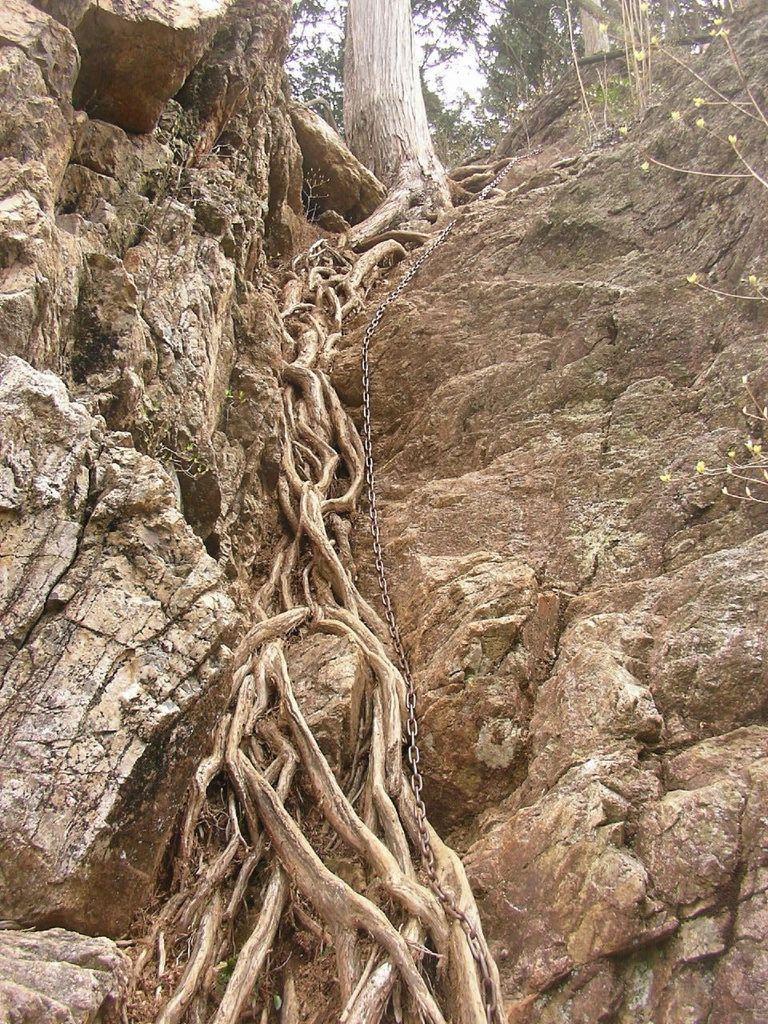What type of plant or vegetation can be seen in the image? There are roots visible in the image. What object can be seen on the hill in the image? There is a chain on the hill in the image. What is located at the top of the image? There is a stem at the top of the image. What type of skirt is hanging from the stem at the top of the image? There is no skirt present in the image; it features roots, a chain, and a stem. Can you spot any jellyfish in the image? There are no jellyfish present in the image. 